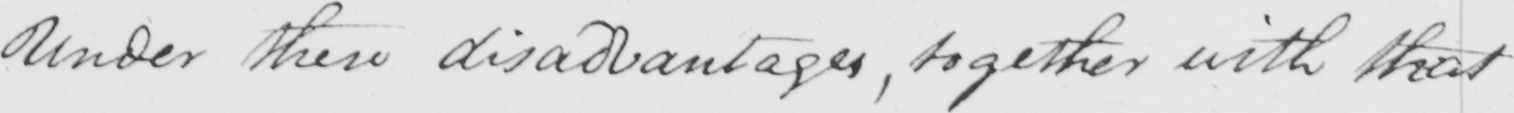Can you tell me what this handwritten text says? Under these disadvantages , together with that 